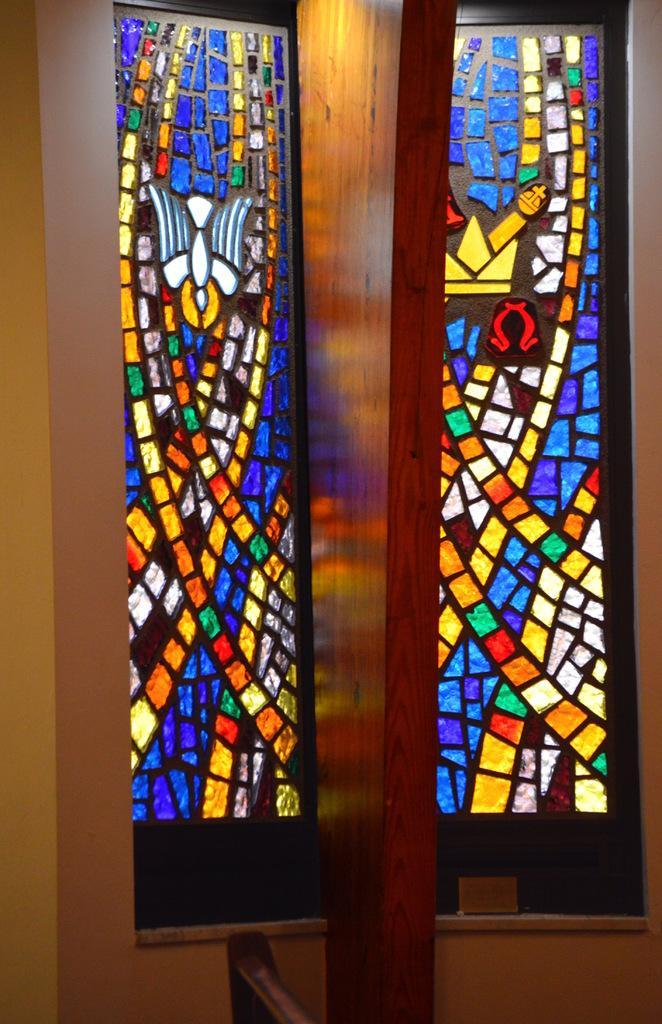Please provide a concise description of this image. In this image there are stained glass windows in the background. In the front there is a wall and in the center of the windows there is a wooden partition. 